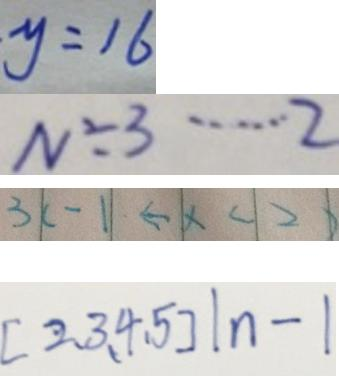Convert formula to latex. <formula><loc_0><loc_0><loc_500><loc_500>y = 1 6 
 N \div 3 \cdots 2 
 3 \vert c - 1 \vert \leftarrow \vert x < \vert 2 \vert 
 [ 2 , 3 , 4 , 5 ] \vert n - \vert</formula> 